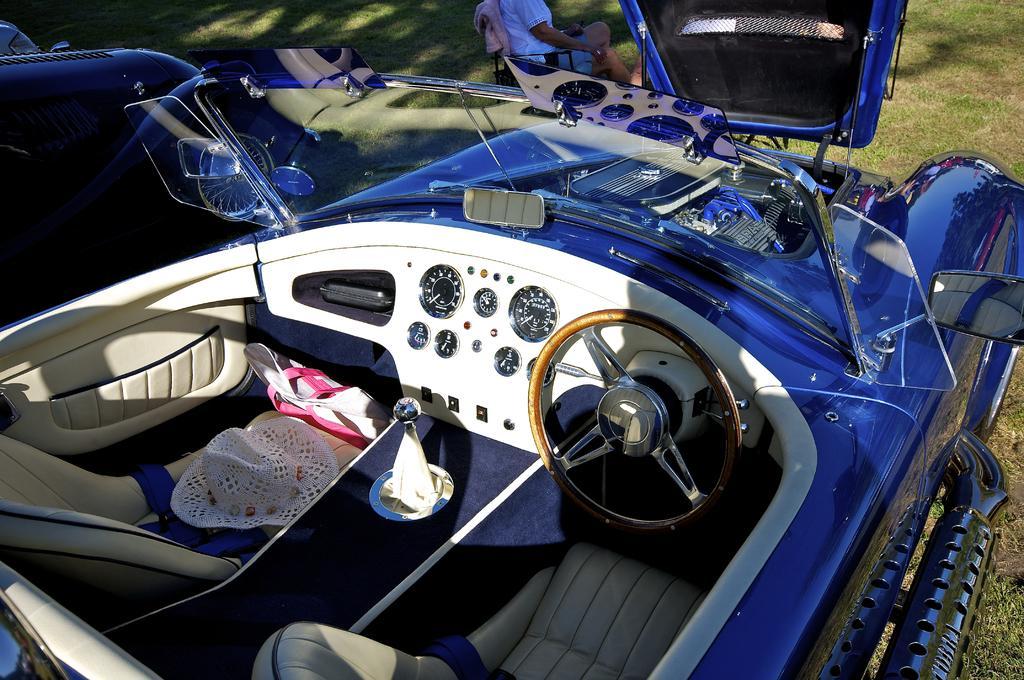Describe this image in one or two sentences. In the image in the center we can see one blue color vehicle. In the vehicle,we can see tissue papers,seats,hat,cloth,steering wheel and few other objects. In the background we can see grass and one person sitting on the chair. 